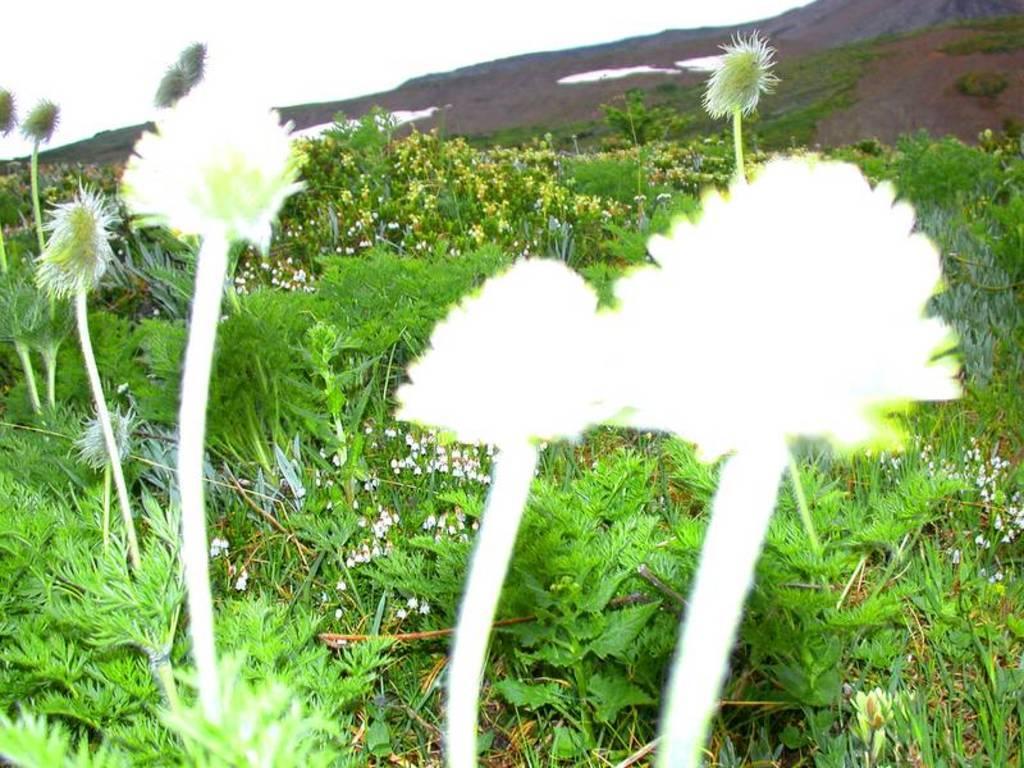Could you give a brief overview of what you see in this image? In the picture we can see plants and flowers. In the background there is sky. 